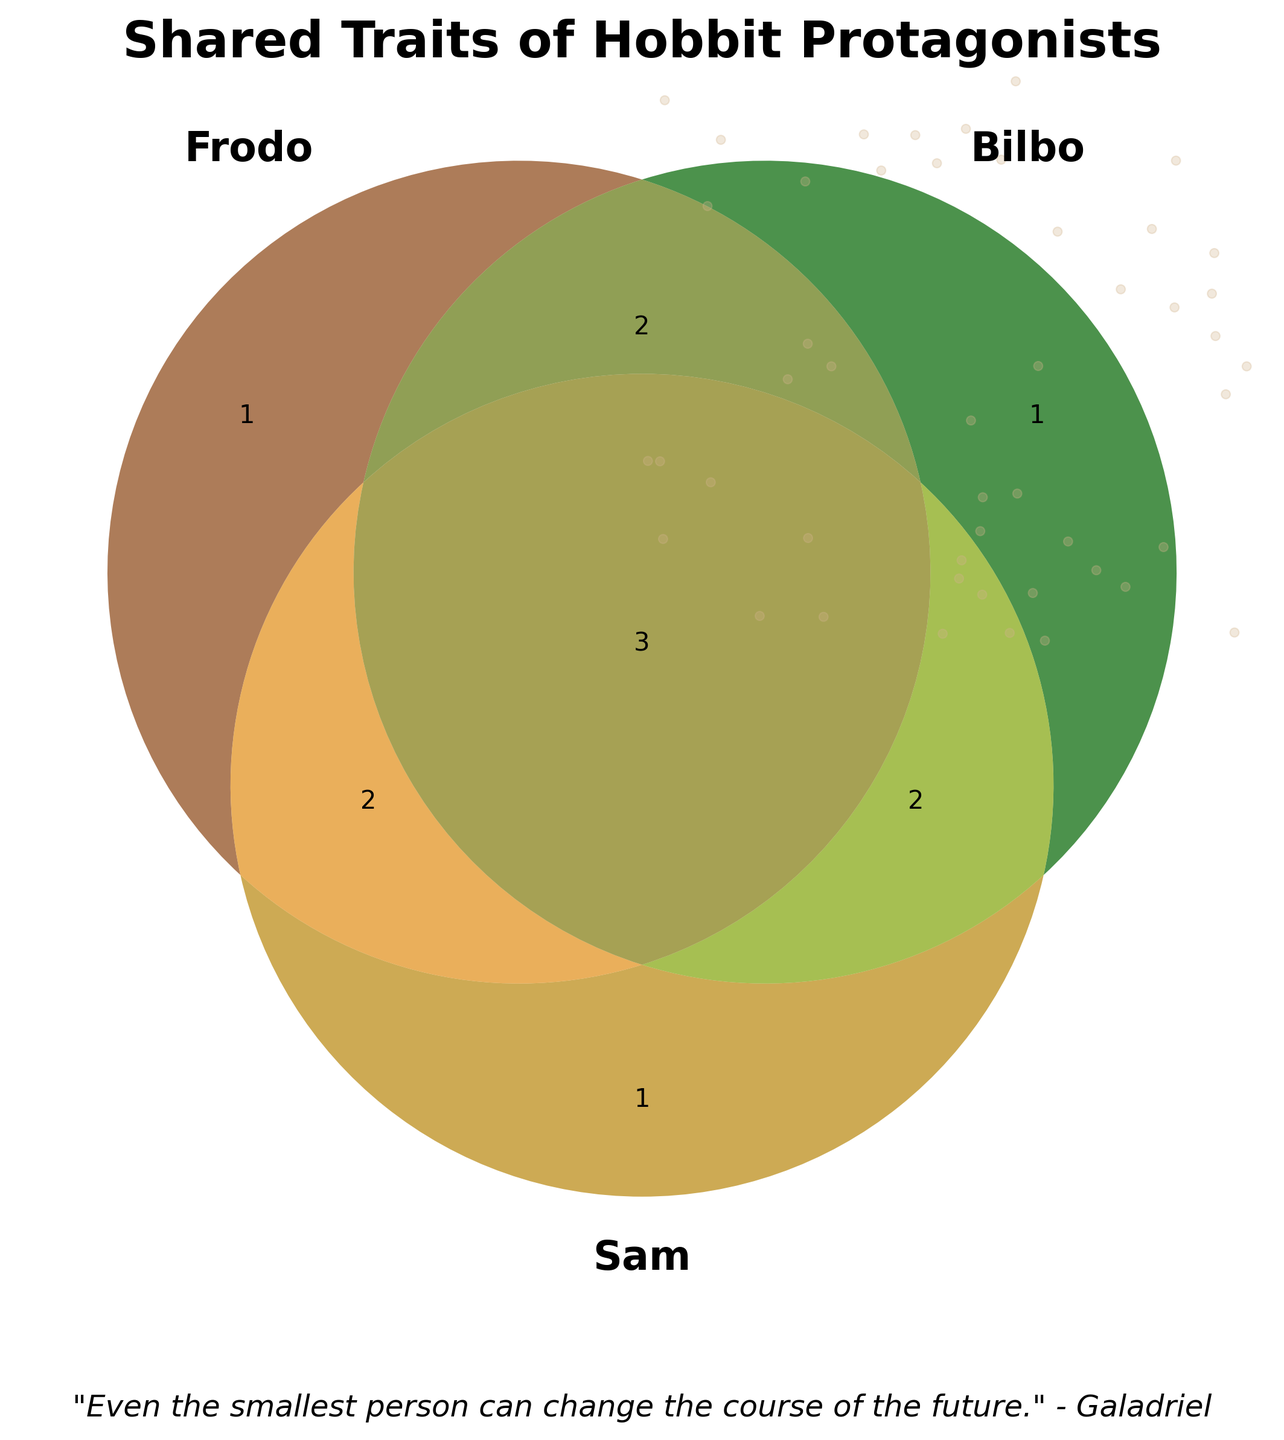what is the key color representing Frodo? The Venn diagram uses distinct colors for each hobbit. Frodo is represented by the brown circle.
Answer: brown How many traits are unique to Frodo? The Venn diagram shows a single region inside Frodo's circle that does not overlap with the others. This region contains only one trait.
Answer: 1 Which trait is shared only by Bilbo and Sam? By looking at the overlap area between Bilbo's and Sam's circles, excluding Frodo's circle, you can see two traits. One of them is "Skilled in cooking".
Answer: Skilled in cooking List the traits that all three hobbits share. In the center of the Venn diagram, where all three circles intersect, the traits "Loves food", "Enjoys smoking pipe-weed", and "Values home and comfort" are shared by Frodo, Bilbo, and Sam.
Answer: Loves food, Enjoys smoking pipe-weed, Values home and comfort Which hobbits share the trait "Adventurous spirit"? "Adventurous spirit" falls in the overlap region between Frodo's and Bilbo's circles, excluding Sam's circle. Thus, Frodo and Bilbo share this trait.
Answer: Frodo and Bilbo What is unique to Bilbo only? The Venn diagram shows the segment of Bilbo's circle that does not overlap with the others. This area contains one trait: "Expert riddle-solver".
Answer: Expert riddle-solver How many traits do Frodo and Sam share that Bilbo does not? Frodo and Sam share two traits that Bilbo does not, visible in the overlap between Frodo's and Sam's circles, excluding Bilbo's circle.
Answer: 2 Which hobbit is devoted to Rosie Cotton? The Venn diagram shows "Devoted to Rosie Cotton" in Sam's exclusive section, meaning this trait belongs only to Sam.
Answer: Sam How many total traits are unique to each hobbit? Frodo has 1 unique trait, Bilbo has 1 unique trait, and Sam has 1 unique trait. Adding these gives a total of 3 unique traits.
Answer: 3 Which hobbit is the Bearer of the One Ring? The Venn diagram places "Bearer of the One Ring" in the section exclusive to Frodo, implying only Frodo has this trait.
Answer: Frodo 